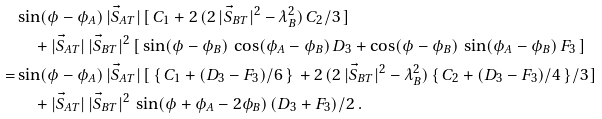Convert formula to latex. <formula><loc_0><loc_0><loc_500><loc_500>& \sin ( \phi - \phi _ { A } ) \, | \vec { S } _ { A T } | \, [ \, C _ { 1 } + 2 \, ( 2 \, | \vec { S } _ { B T } | ^ { 2 } - \lambda _ { B } ^ { 2 } ) \, C _ { 2 } / 3 \, ] \\ & \quad + | \vec { S } _ { A T } | \, | \vec { S } _ { B T } | ^ { 2 } \, [ \, \sin ( \phi - \phi _ { B } ) \, \cos ( \phi _ { A } - \phi _ { B } ) \, D _ { 3 } + \cos ( \phi - \phi _ { B } ) \, \sin ( \phi _ { A } - \phi _ { B } ) \, F _ { 3 } \, ] \\ = & \sin ( \phi - \phi _ { A } ) \, | \vec { S } _ { A T } | \, [ \, \{ \, C _ { 1 } + ( D _ { 3 } - F _ { 3 } ) / 6 \, \} \, + 2 \, ( 2 \, | \vec { S } _ { B T } | ^ { 2 } - \lambda _ { B } ^ { 2 } ) \, \{ \, C _ { 2 } + ( D _ { 3 } - F _ { 3 } ) / 4 \, \} / 3 \, ] \\ & \quad + | \vec { S } _ { A T } | \, | \vec { S } _ { B T } | ^ { 2 } \, \sin ( \phi + \phi _ { A } - 2 \phi _ { B } ) \, ( D _ { 3 } + F _ { 3 } ) / 2 \ .</formula> 